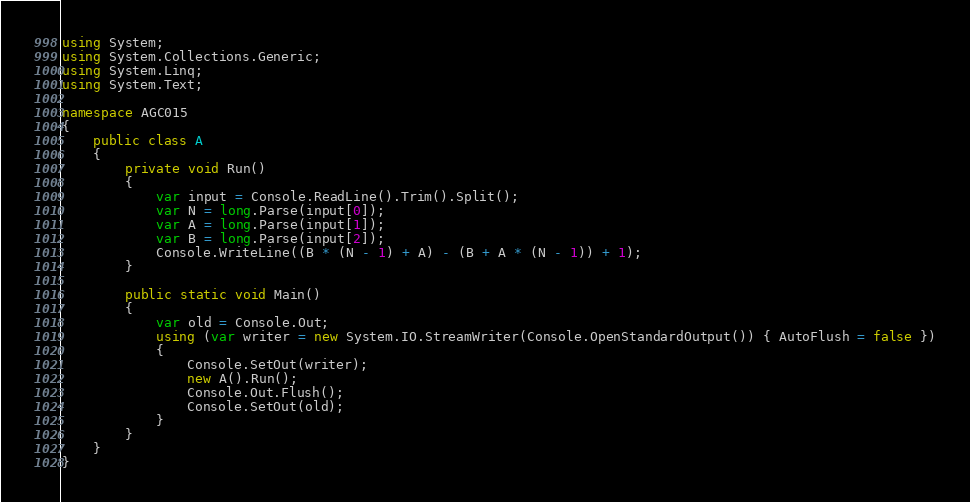Convert code to text. <code><loc_0><loc_0><loc_500><loc_500><_C#_>using System;
using System.Collections.Generic;
using System.Linq;
using System.Text;

namespace AGC015
{
    public class A
    {
        private void Run()
        {
            var input = Console.ReadLine().Trim().Split();
            var N = long.Parse(input[0]);
            var A = long.Parse(input[1]);
            var B = long.Parse(input[2]);
            Console.WriteLine((B * (N - 1) + A) - (B + A * (N - 1)) + 1);
        }

        public static void Main()
        {
            var old = Console.Out;
            using (var writer = new System.IO.StreamWriter(Console.OpenStandardOutput()) { AutoFlush = false })
            {
                Console.SetOut(writer);
                new A().Run();
                Console.Out.Flush();
                Console.SetOut(old);
            }
        }
    }
}
</code> 